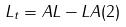Convert formula to latex. <formula><loc_0><loc_0><loc_500><loc_500>L _ { t } = A L - L A ( 2 )</formula> 